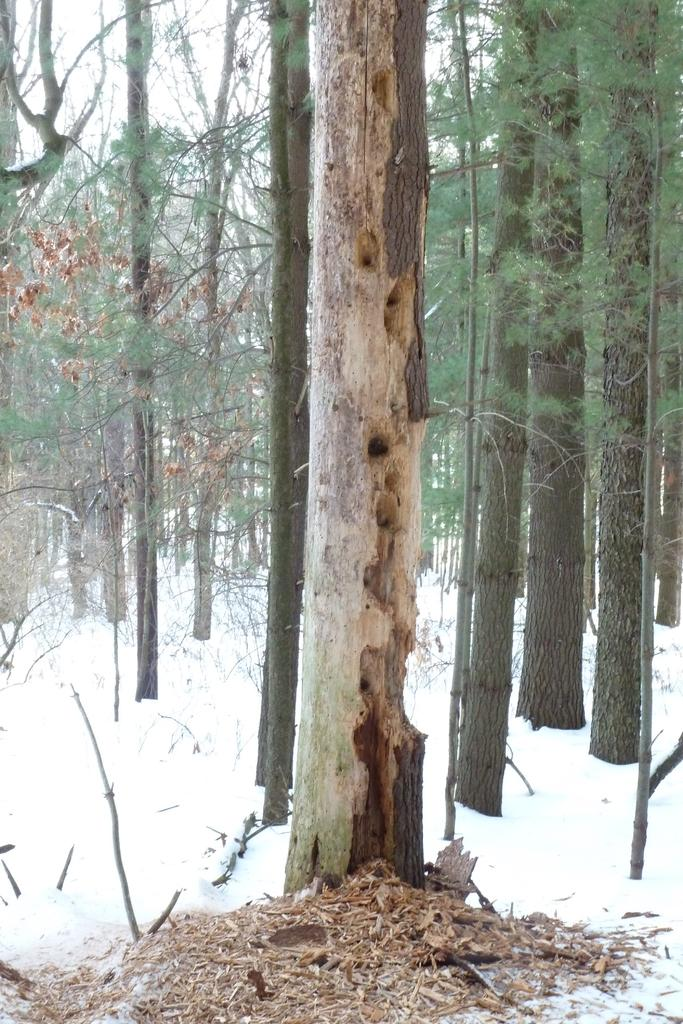What type of vegetation is present in the image? There are many trees in the image. What is the weather like in the image? There is snow on the left side of the image, indicating a cold and snowy environment. What is visible at the top of the image? The sky is visible at the top of the image. What type of street can be seen in the image? There is no street present in the image; it features many trees and snow. 